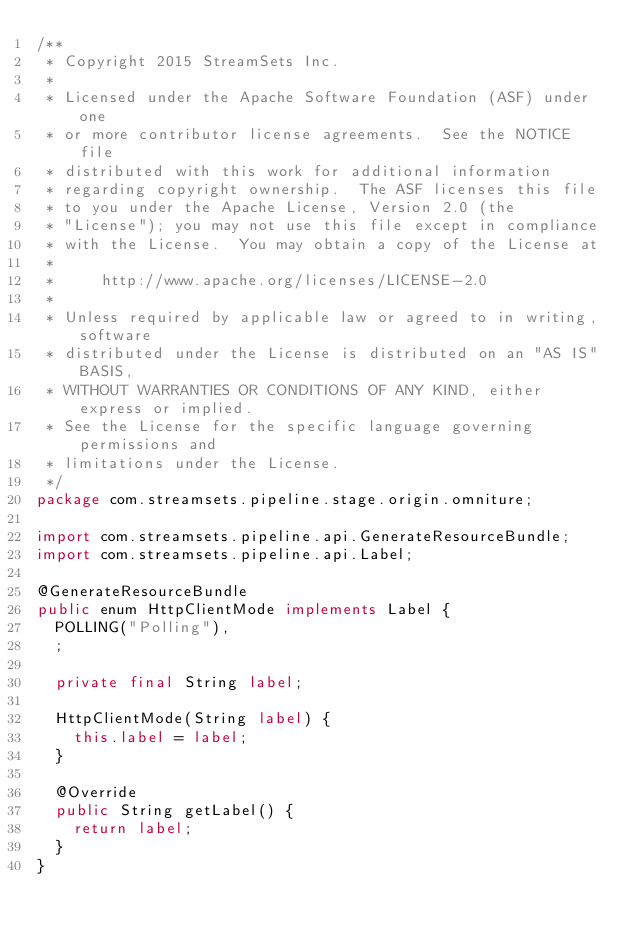Convert code to text. <code><loc_0><loc_0><loc_500><loc_500><_Java_>/**
 * Copyright 2015 StreamSets Inc.
 *
 * Licensed under the Apache Software Foundation (ASF) under one
 * or more contributor license agreements.  See the NOTICE file
 * distributed with this work for additional information
 * regarding copyright ownership.  The ASF licenses this file
 * to you under the Apache License, Version 2.0 (the
 * "License"); you may not use this file except in compliance
 * with the License.  You may obtain a copy of the License at
 *
 *     http://www.apache.org/licenses/LICENSE-2.0
 *
 * Unless required by applicable law or agreed to in writing, software
 * distributed under the License is distributed on an "AS IS" BASIS,
 * WITHOUT WARRANTIES OR CONDITIONS OF ANY KIND, either express or implied.
 * See the License for the specific language governing permissions and
 * limitations under the License.
 */
package com.streamsets.pipeline.stage.origin.omniture;

import com.streamsets.pipeline.api.GenerateResourceBundle;
import com.streamsets.pipeline.api.Label;

@GenerateResourceBundle
public enum HttpClientMode implements Label {
  POLLING("Polling"),
  ;

  private final String label;

  HttpClientMode(String label) {
    this.label = label;
  }

  @Override
  public String getLabel() {
    return label;
  }
}
</code> 